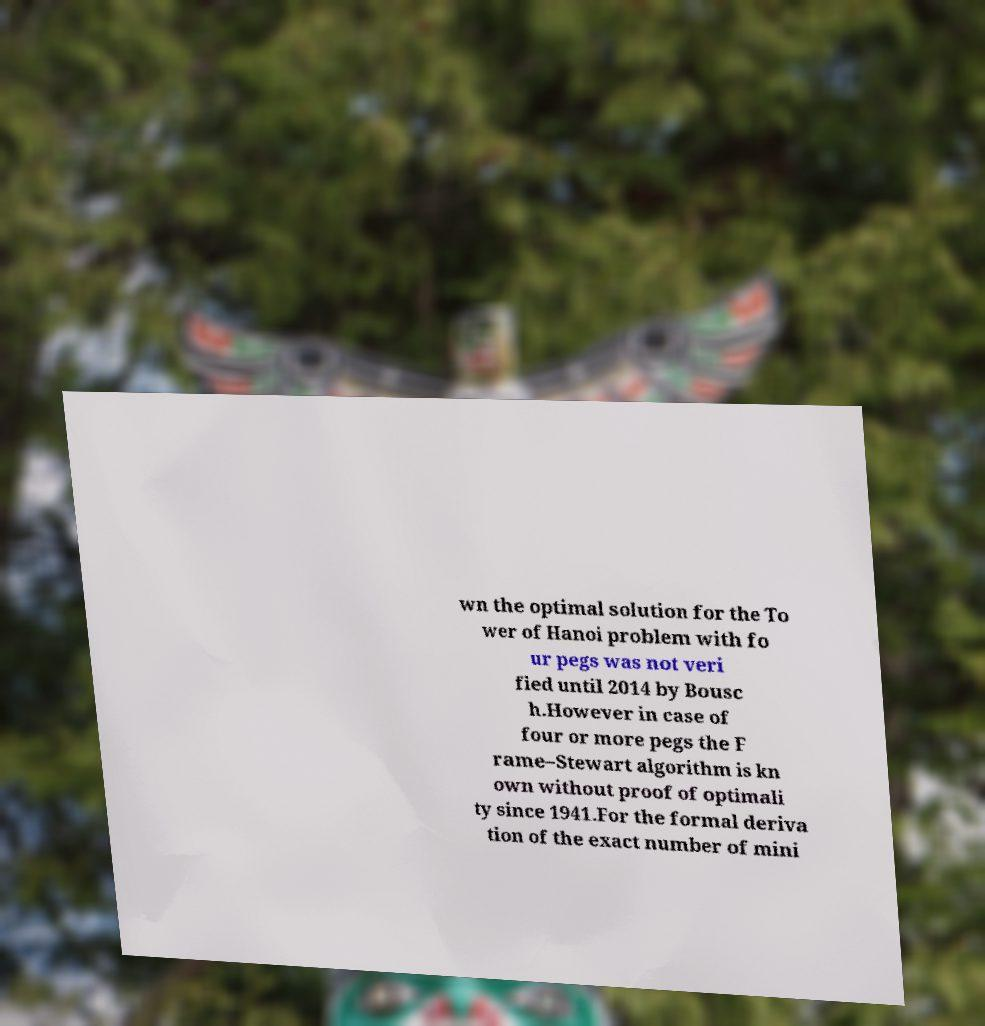Please read and relay the text visible in this image. What does it say? wn the optimal solution for the To wer of Hanoi problem with fo ur pegs was not veri fied until 2014 by Bousc h.However in case of four or more pegs the F rame–Stewart algorithm is kn own without proof of optimali ty since 1941.For the formal deriva tion of the exact number of mini 